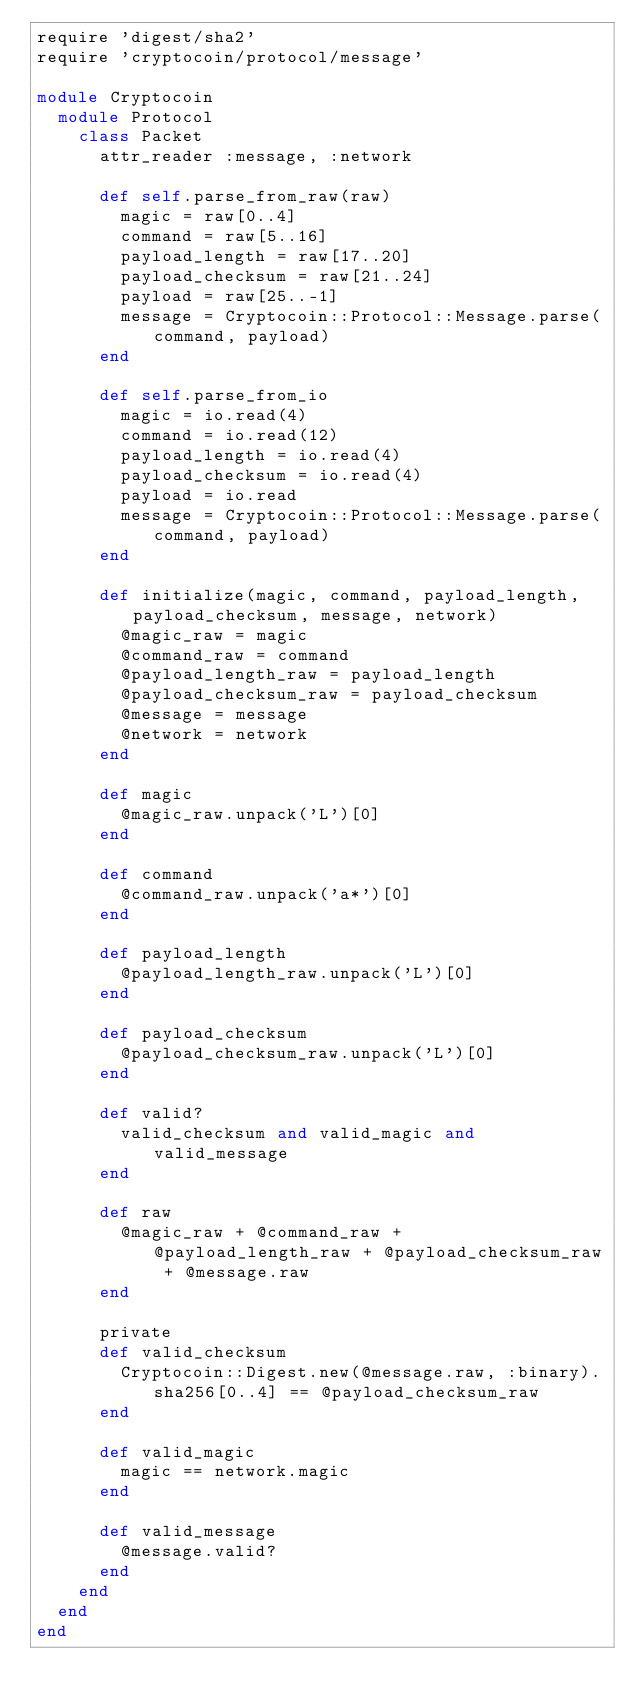Convert code to text. <code><loc_0><loc_0><loc_500><loc_500><_Ruby_>require 'digest/sha2'
require 'cryptocoin/protocol/message'

module Cryptocoin
  module Protocol
    class Packet
      attr_reader :message, :network
      
      def self.parse_from_raw(raw)
        magic = raw[0..4]
        command = raw[5..16]
        payload_length = raw[17..20]
        payload_checksum = raw[21..24]
        payload = raw[25..-1]
        message = Cryptocoin::Protocol::Message.parse(command, payload)
      end
      
      def self.parse_from_io
        magic = io.read(4)
        command = io.read(12)
        payload_length = io.read(4)
        payload_checksum = io.read(4)
        payload = io.read
        message = Cryptocoin::Protocol::Message.parse(command, payload)
      end
      
      def initialize(magic, command, payload_length, payload_checksum, message, network)
        @magic_raw = magic
        @command_raw = command
        @payload_length_raw = payload_length
        @payload_checksum_raw = payload_checksum
        @message = message
        @network = network
      end
      
      def magic
        @magic_raw.unpack('L')[0]
      end
      
      def command
        @command_raw.unpack('a*')[0]
      end
      
      def payload_length
        @payload_length_raw.unpack('L')[0]
      end
      
      def payload_checksum
        @payload_checksum_raw.unpack('L')[0]
      end

      def valid?
        valid_checksum and valid_magic and valid_message
      end
      
      def raw
        @magic_raw + @command_raw + @payload_length_raw + @payload_checksum_raw + @message.raw
      end

      private
      def valid_checksum
        Cryptocoin::Digest.new(@message.raw, :binary).sha256[0..4] == @payload_checksum_raw
      end

      def valid_magic
        magic == network.magic
      end

      def valid_message
        @message.valid?
      end
    end
  end
end
</code> 